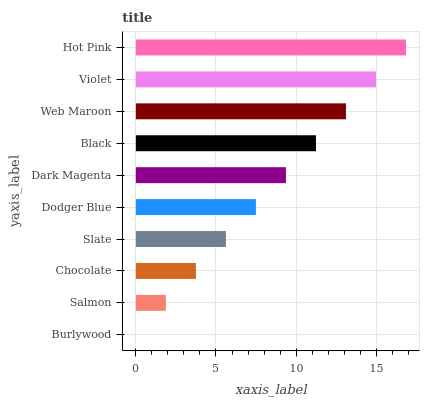Is Burlywood the minimum?
Answer yes or no. Yes. Is Hot Pink the maximum?
Answer yes or no. Yes. Is Salmon the minimum?
Answer yes or no. No. Is Salmon the maximum?
Answer yes or no. No. Is Salmon greater than Burlywood?
Answer yes or no. Yes. Is Burlywood less than Salmon?
Answer yes or no. Yes. Is Burlywood greater than Salmon?
Answer yes or no. No. Is Salmon less than Burlywood?
Answer yes or no. No. Is Dark Magenta the high median?
Answer yes or no. Yes. Is Dodger Blue the low median?
Answer yes or no. Yes. Is Chocolate the high median?
Answer yes or no. No. Is Burlywood the low median?
Answer yes or no. No. 